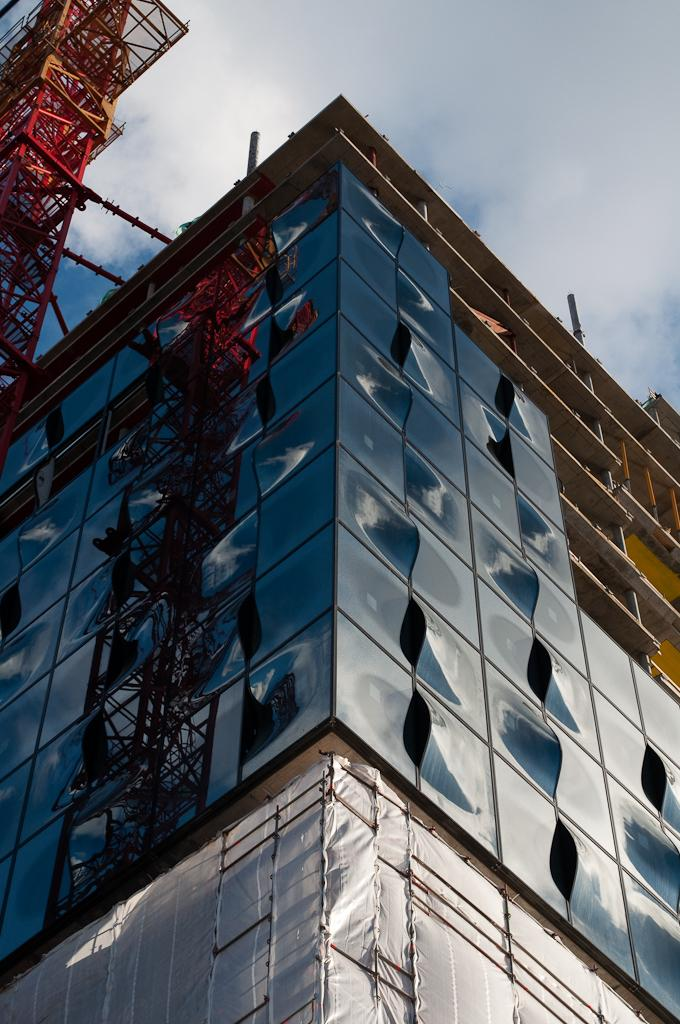What type of building is in the foreground of the image? There is a glass building in the foreground of the image. What can be seen on the left side of the image? There is a tower on the left side of the image. What is visible in the background of the image? The sky is visible in the image. What can be observed in the sky? Clouds are present in the sky. What type of plants are being traded in the image? There is no indication of any plants or trade in the image. 